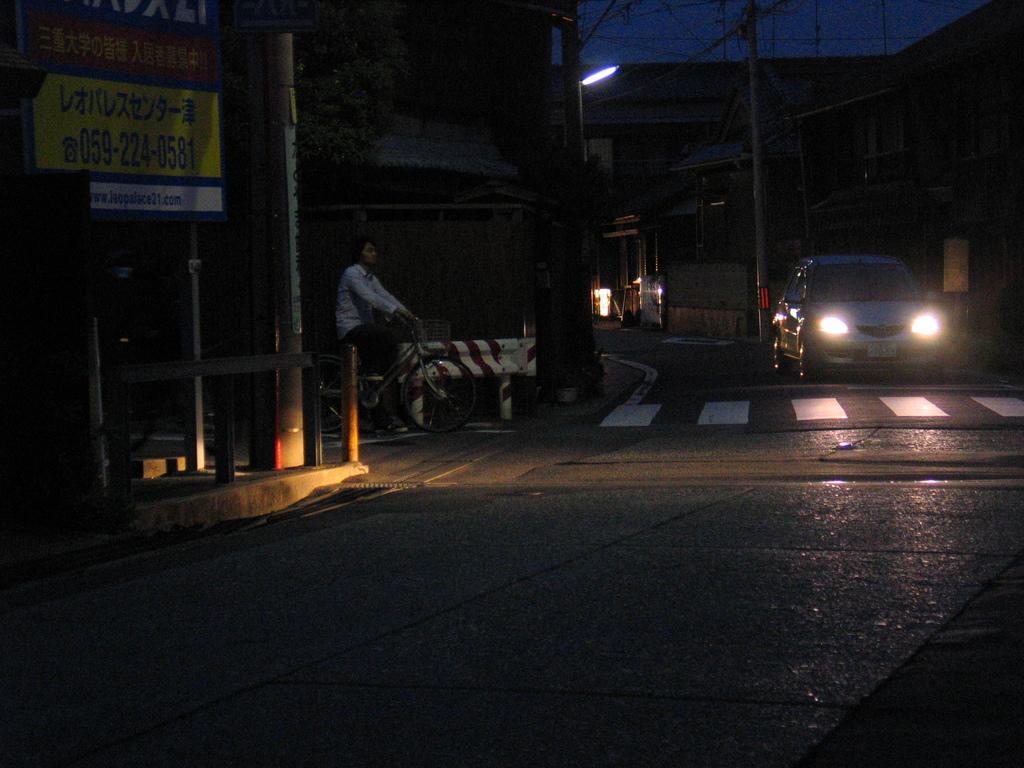Could you give a brief overview of what you see in this image? In this picture there is a car on the right side of the image and there is a man on a bicycle in the center of the image, there are posters on the wall, on the left side of the image, there are buildings and poles in the background area of the image. 